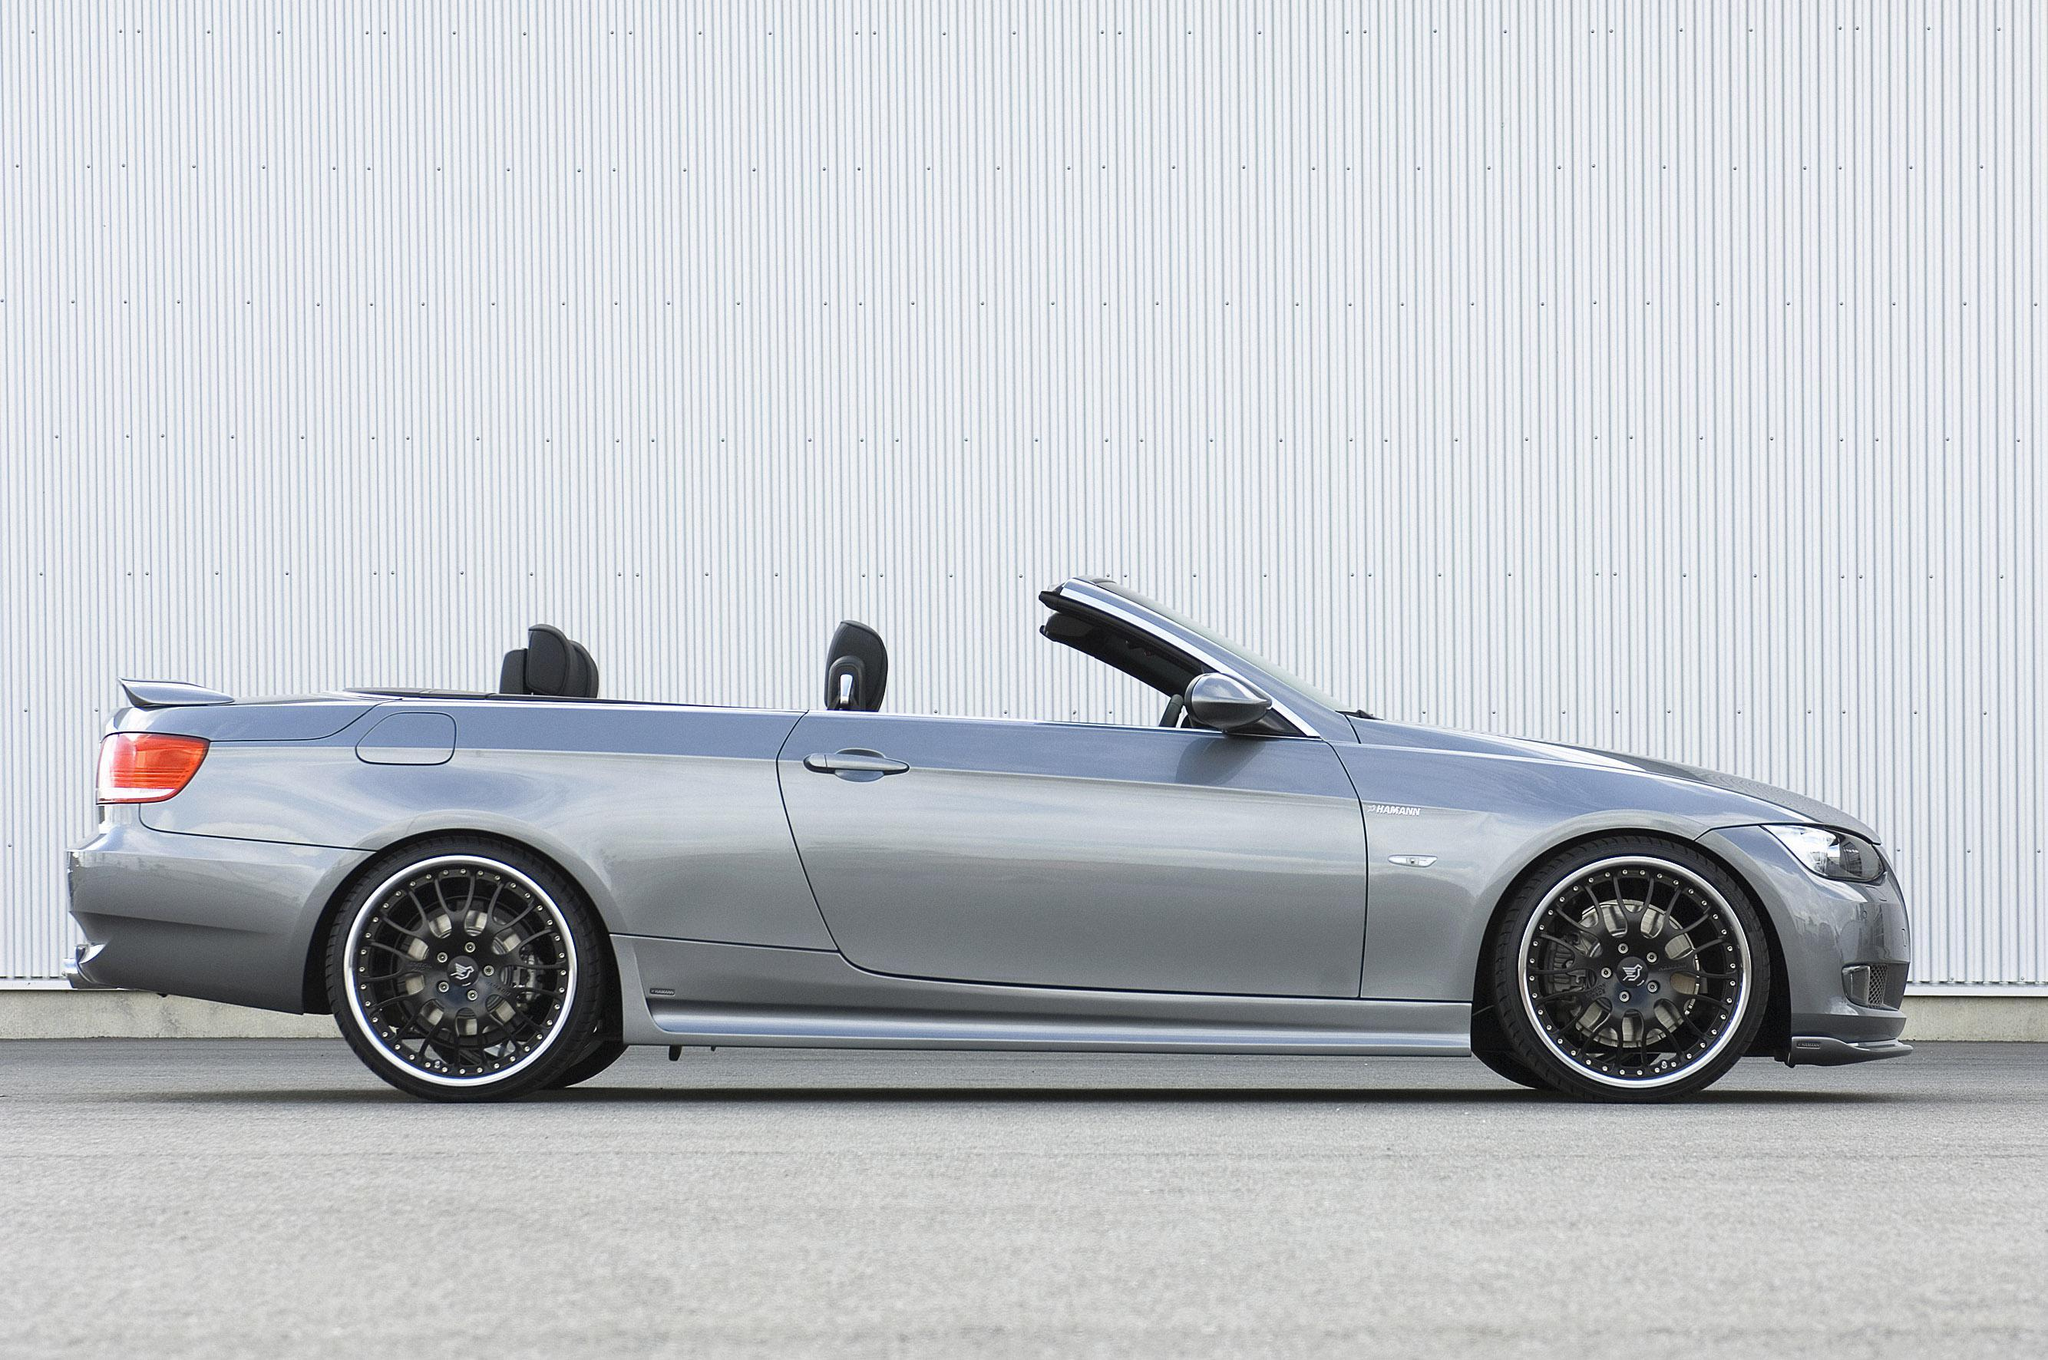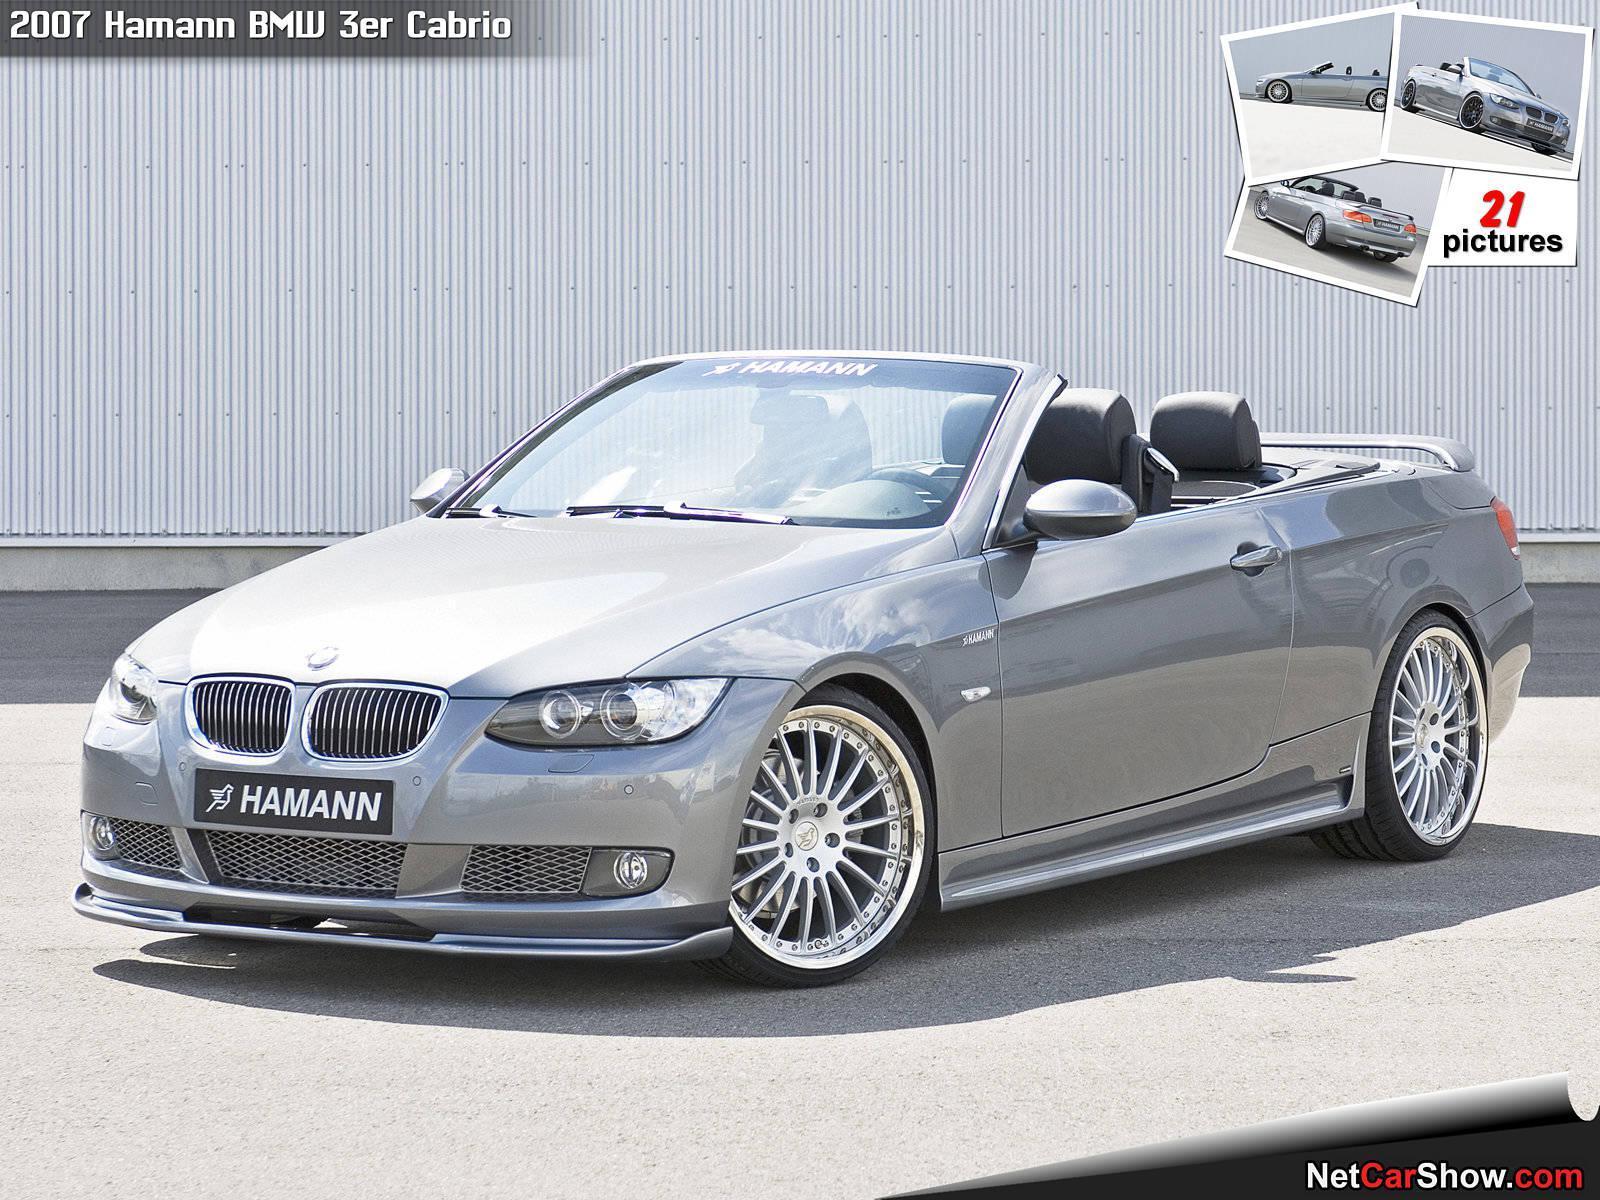The first image is the image on the left, the second image is the image on the right. Assess this claim about the two images: "One convertible faces away from the camera, and the other is silver and facing rightward.". Correct or not? Answer yes or no. No. The first image is the image on the left, the second image is the image on the right. Given the left and right images, does the statement "An image has a blue convertible sports car." hold true? Answer yes or no. No. 